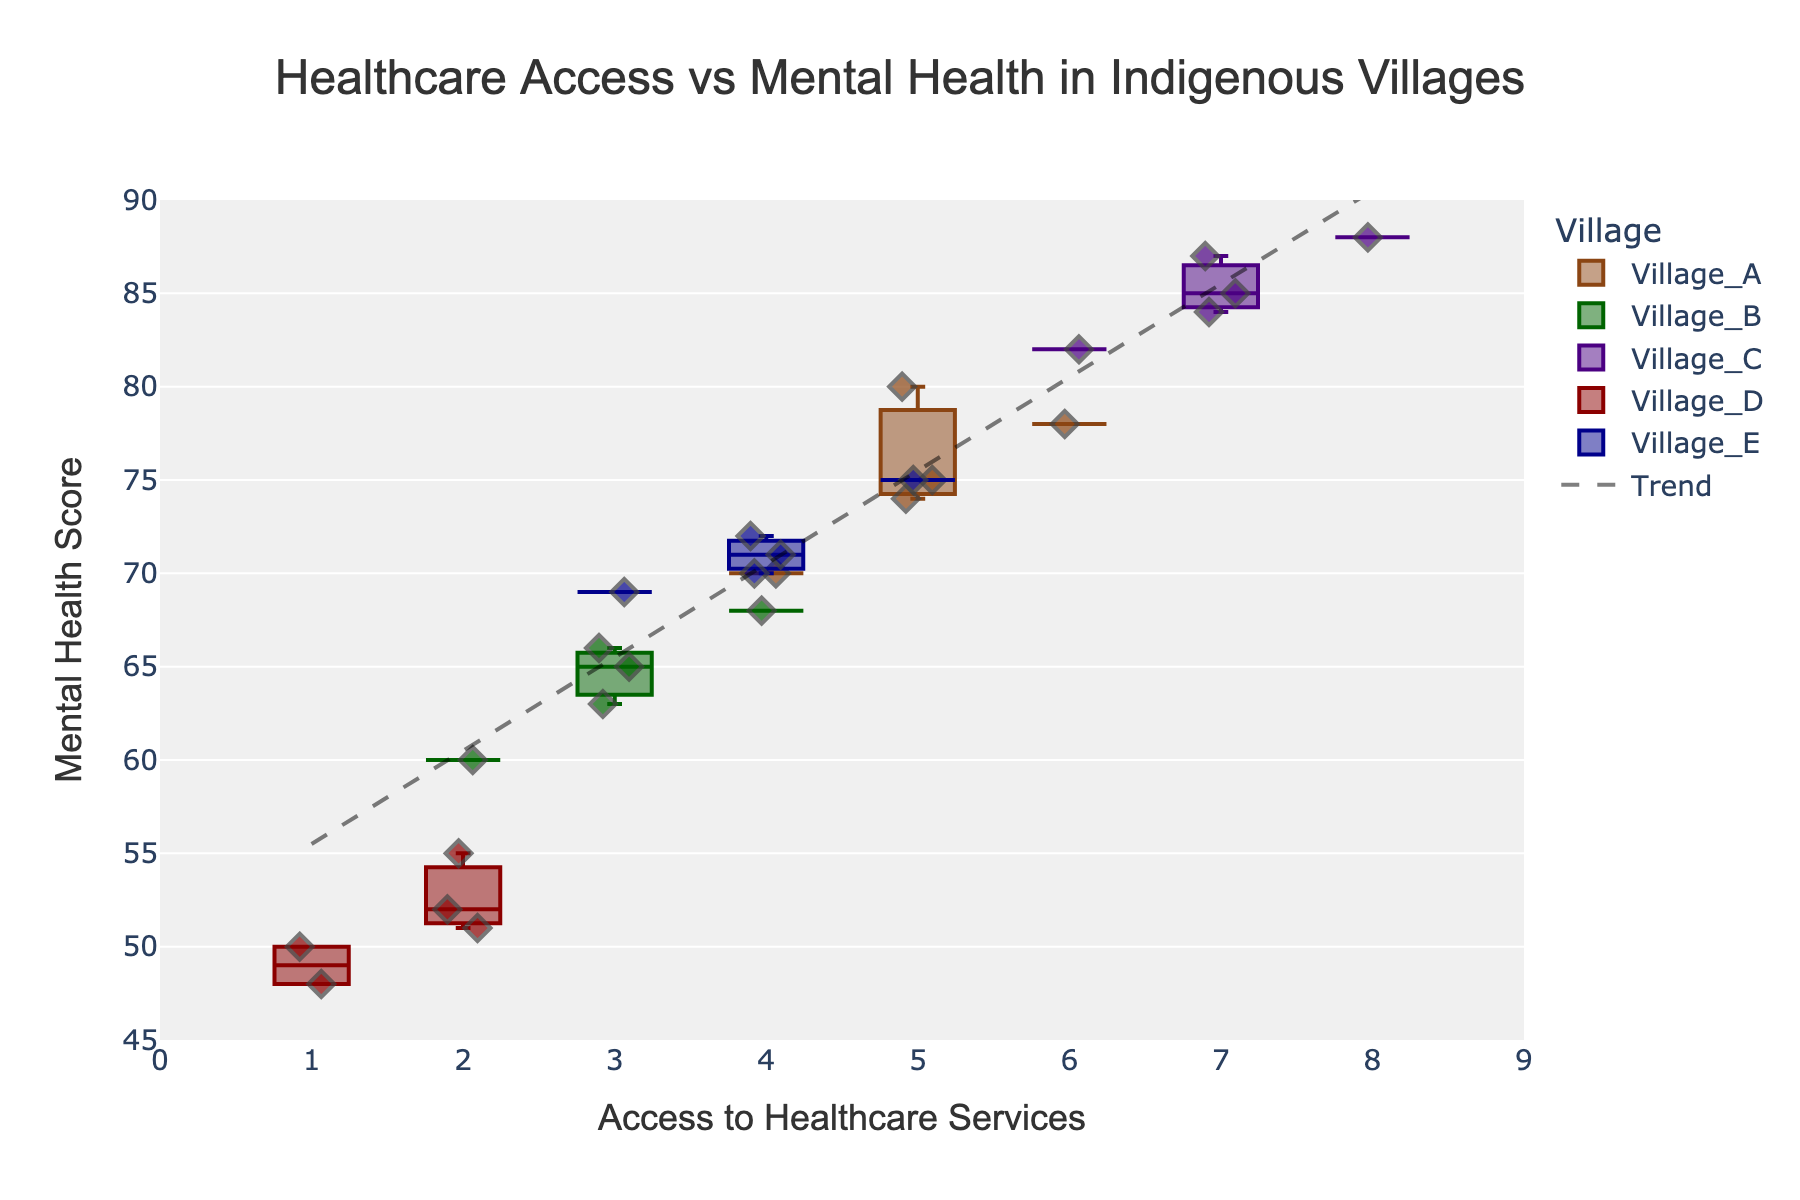What is the title of the plot? The title is placed at the top center of the figure, which is usually the largest text on the plot.
Answer: Healthcare Access vs Mental Health in Indigenous Villages How many villages are represented in the plot? By looking at the legend or the distinct number of box plots, we can count the unique villages.
Answer: 5 Which village has the highest median mental health score? The median value of a box plot is often indicated by the line inside the box. By comparing these median lines, we can identify the village with the highest one.
Answer: Village_C What is the range of Access to Healthcare Services in Village_B? The range can be found by inspecting the smallest and largest data points for the scatter points within Village_B's box plot.
Answer: 2 to 4 Which village shows the highest variability in Mental Health Scores? Variability is indicated by the length of the box (interquartile range) and the whiskers. The village with the longest combined box and whiskers shows the highest variability.
Answer: Village_B What is the general trend between Access to Healthcare Services and Mental Health Score? A trend line is often added to show the overall tendency. By analyzing the slope and direction of the trend line, we can describe the trend.
Answer: Positive correlation Compare the median Mental Health Score of Village_D to Village_E. Look at the lines inside the boxes of both Village_D and Village_E’s box plots. Compare their positions on the y-axis.
Answer: Village_E has a higher median than Village_D What does the box plot for Village_A indicate about the distribution of Mental Health Scores? A box plot provides insights into the spread, central tendency, and presence of outliers. Examine the box and whiskers to interpret these aspects for Village_A.
Answer: Scores are fairly consistent around the central tendency (median) Which village appears to benefit the most from Access to Healthcare Services in terms of high Mental Health Scores? Identify the village with consistently higher mental health scores associated with higher access values.
Answer: Village_C What is the average Access to Healthcare Services for Village_E? Sum the access values for all data points in Village_E and divide by the number of data points.
Answer: (4 + 4 + 5 + 4 + 3) / 5 = 4 